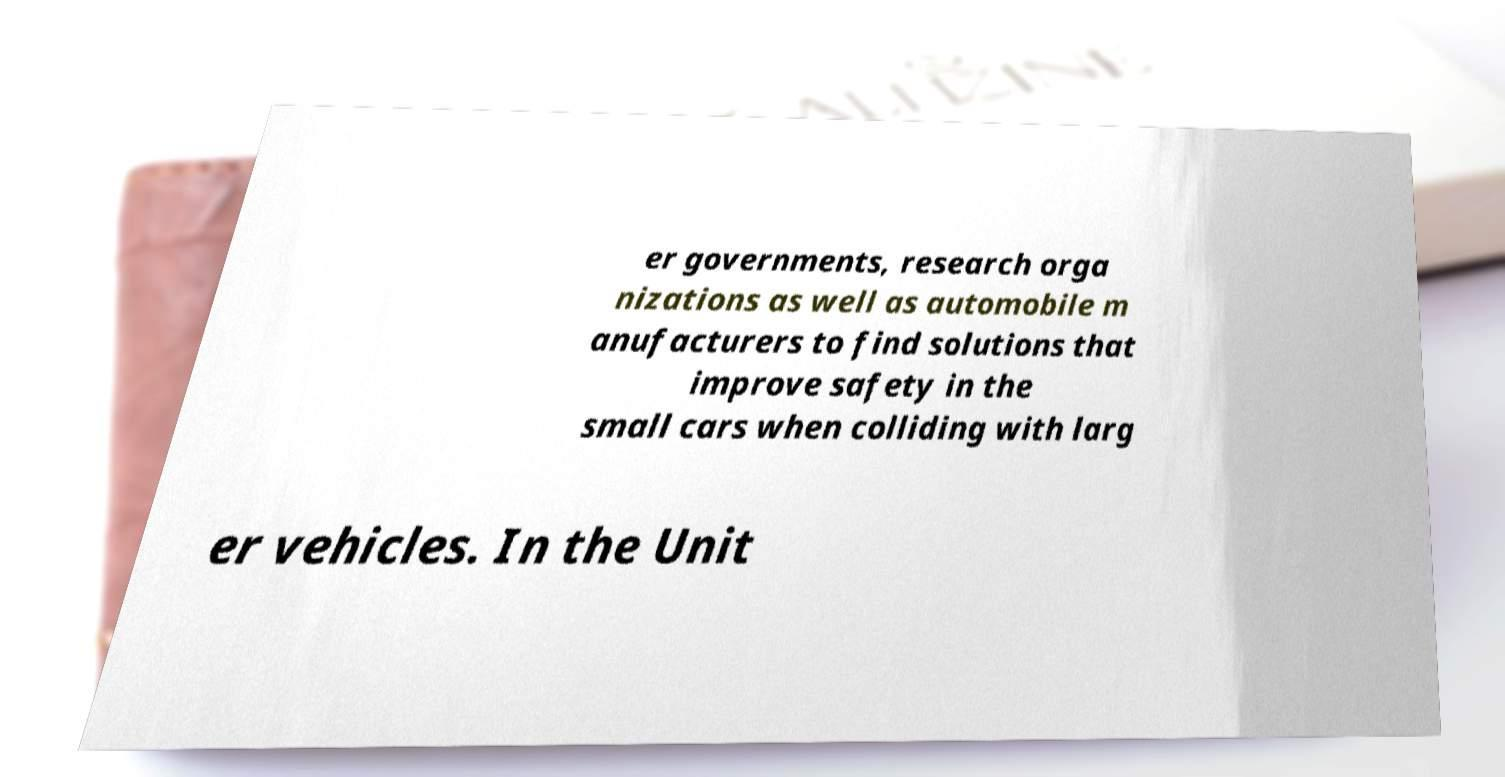Could you extract and type out the text from this image? er governments, research orga nizations as well as automobile m anufacturers to find solutions that improve safety in the small cars when colliding with larg er vehicles. In the Unit 